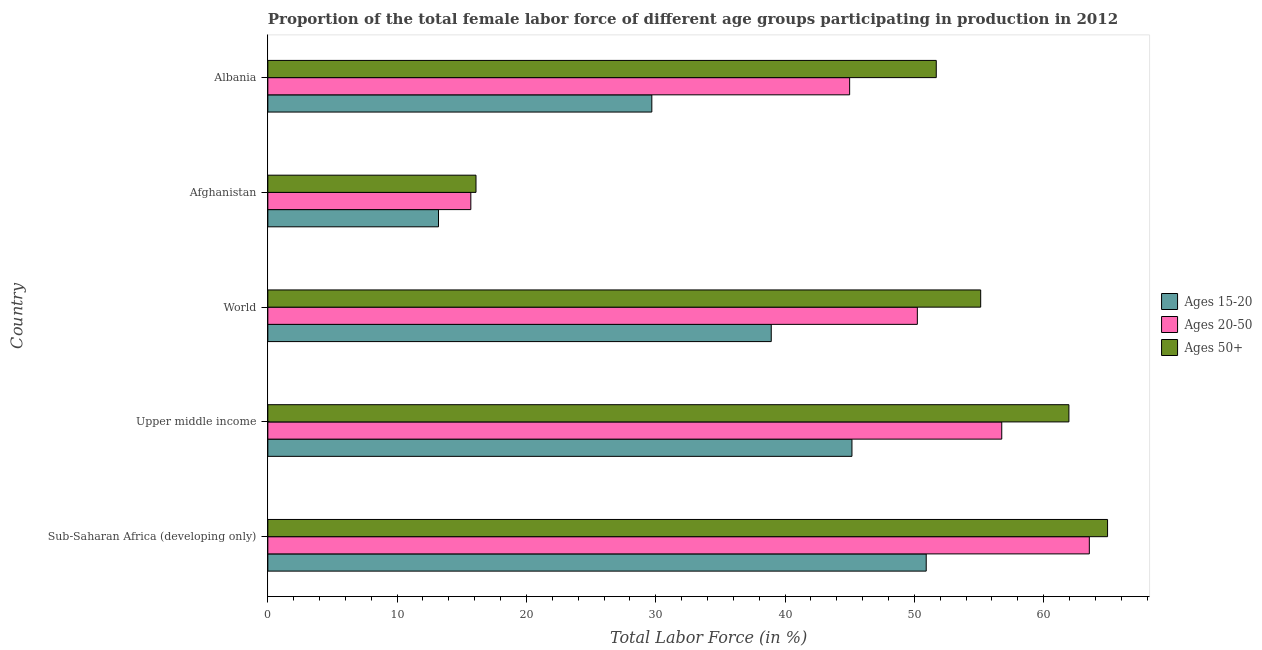What is the label of the 5th group of bars from the top?
Your response must be concise. Sub-Saharan Africa (developing only). What is the percentage of female labor force within the age group 15-20 in Afghanistan?
Your response must be concise. 13.2. Across all countries, what is the maximum percentage of female labor force within the age group 20-50?
Keep it short and to the point. 63.54. Across all countries, what is the minimum percentage of female labor force within the age group 20-50?
Your answer should be compact. 15.7. In which country was the percentage of female labor force above age 50 maximum?
Provide a short and direct response. Sub-Saharan Africa (developing only). In which country was the percentage of female labor force within the age group 15-20 minimum?
Make the answer very short. Afghanistan. What is the total percentage of female labor force above age 50 in the graph?
Ensure brevity in your answer.  249.84. What is the difference between the percentage of female labor force within the age group 20-50 in Afghanistan and that in World?
Your answer should be compact. -34.54. What is the difference between the percentage of female labor force above age 50 in Albania and the percentage of female labor force within the age group 15-20 in Upper middle income?
Give a very brief answer. 6.52. What is the average percentage of female labor force within the age group 15-20 per country?
Your answer should be compact. 35.59. What is the ratio of the percentage of female labor force above age 50 in Albania to that in Upper middle income?
Provide a succinct answer. 0.83. Is the difference between the percentage of female labor force above age 50 in Upper middle income and World greater than the difference between the percentage of female labor force within the age group 20-50 in Upper middle income and World?
Provide a succinct answer. Yes. What is the difference between the highest and the second highest percentage of female labor force above age 50?
Your response must be concise. 2.99. What is the difference between the highest and the lowest percentage of female labor force within the age group 15-20?
Give a very brief answer. 37.72. What does the 3rd bar from the top in Upper middle income represents?
Keep it short and to the point. Ages 15-20. What does the 3rd bar from the bottom in Afghanistan represents?
Provide a short and direct response. Ages 50+. Are all the bars in the graph horizontal?
Give a very brief answer. Yes. What is the difference between two consecutive major ticks on the X-axis?
Your answer should be very brief. 10. Does the graph contain grids?
Offer a very short reply. No. Where does the legend appear in the graph?
Ensure brevity in your answer.  Center right. How many legend labels are there?
Make the answer very short. 3. What is the title of the graph?
Your answer should be very brief. Proportion of the total female labor force of different age groups participating in production in 2012. Does "Primary education" appear as one of the legend labels in the graph?
Your response must be concise. No. What is the label or title of the X-axis?
Provide a short and direct response. Total Labor Force (in %). What is the label or title of the Y-axis?
Offer a very short reply. Country. What is the Total Labor Force (in %) of Ages 15-20 in Sub-Saharan Africa (developing only)?
Keep it short and to the point. 50.92. What is the Total Labor Force (in %) of Ages 20-50 in Sub-Saharan Africa (developing only)?
Give a very brief answer. 63.54. What is the Total Labor Force (in %) of Ages 50+ in Sub-Saharan Africa (developing only)?
Your answer should be very brief. 64.95. What is the Total Labor Force (in %) of Ages 15-20 in Upper middle income?
Your answer should be very brief. 45.18. What is the Total Labor Force (in %) in Ages 20-50 in Upper middle income?
Your answer should be very brief. 56.76. What is the Total Labor Force (in %) of Ages 50+ in Upper middle income?
Offer a very short reply. 61.96. What is the Total Labor Force (in %) in Ages 15-20 in World?
Offer a very short reply. 38.94. What is the Total Labor Force (in %) of Ages 20-50 in World?
Offer a very short reply. 50.24. What is the Total Labor Force (in %) of Ages 50+ in World?
Your response must be concise. 55.14. What is the Total Labor Force (in %) in Ages 15-20 in Afghanistan?
Offer a very short reply. 13.2. What is the Total Labor Force (in %) in Ages 20-50 in Afghanistan?
Keep it short and to the point. 15.7. What is the Total Labor Force (in %) in Ages 50+ in Afghanistan?
Provide a succinct answer. 16.1. What is the Total Labor Force (in %) of Ages 15-20 in Albania?
Ensure brevity in your answer.  29.7. What is the Total Labor Force (in %) in Ages 50+ in Albania?
Provide a short and direct response. 51.7. Across all countries, what is the maximum Total Labor Force (in %) in Ages 15-20?
Provide a short and direct response. 50.92. Across all countries, what is the maximum Total Labor Force (in %) in Ages 20-50?
Make the answer very short. 63.54. Across all countries, what is the maximum Total Labor Force (in %) in Ages 50+?
Offer a terse response. 64.95. Across all countries, what is the minimum Total Labor Force (in %) in Ages 15-20?
Provide a succinct answer. 13.2. Across all countries, what is the minimum Total Labor Force (in %) in Ages 20-50?
Make the answer very short. 15.7. Across all countries, what is the minimum Total Labor Force (in %) of Ages 50+?
Provide a succinct answer. 16.1. What is the total Total Labor Force (in %) of Ages 15-20 in the graph?
Your answer should be compact. 177.94. What is the total Total Labor Force (in %) of Ages 20-50 in the graph?
Provide a succinct answer. 231.24. What is the total Total Labor Force (in %) in Ages 50+ in the graph?
Your response must be concise. 249.84. What is the difference between the Total Labor Force (in %) in Ages 15-20 in Sub-Saharan Africa (developing only) and that in Upper middle income?
Offer a very short reply. 5.74. What is the difference between the Total Labor Force (in %) in Ages 20-50 in Sub-Saharan Africa (developing only) and that in Upper middle income?
Give a very brief answer. 6.77. What is the difference between the Total Labor Force (in %) in Ages 50+ in Sub-Saharan Africa (developing only) and that in Upper middle income?
Ensure brevity in your answer.  2.99. What is the difference between the Total Labor Force (in %) in Ages 15-20 in Sub-Saharan Africa (developing only) and that in World?
Your answer should be very brief. 11.99. What is the difference between the Total Labor Force (in %) in Ages 20-50 in Sub-Saharan Africa (developing only) and that in World?
Provide a short and direct response. 13.3. What is the difference between the Total Labor Force (in %) in Ages 50+ in Sub-Saharan Africa (developing only) and that in World?
Your answer should be very brief. 9.81. What is the difference between the Total Labor Force (in %) in Ages 15-20 in Sub-Saharan Africa (developing only) and that in Afghanistan?
Provide a succinct answer. 37.72. What is the difference between the Total Labor Force (in %) of Ages 20-50 in Sub-Saharan Africa (developing only) and that in Afghanistan?
Give a very brief answer. 47.84. What is the difference between the Total Labor Force (in %) in Ages 50+ in Sub-Saharan Africa (developing only) and that in Afghanistan?
Give a very brief answer. 48.85. What is the difference between the Total Labor Force (in %) of Ages 15-20 in Sub-Saharan Africa (developing only) and that in Albania?
Offer a very short reply. 21.22. What is the difference between the Total Labor Force (in %) in Ages 20-50 in Sub-Saharan Africa (developing only) and that in Albania?
Give a very brief answer. 18.54. What is the difference between the Total Labor Force (in %) in Ages 50+ in Sub-Saharan Africa (developing only) and that in Albania?
Give a very brief answer. 13.25. What is the difference between the Total Labor Force (in %) of Ages 15-20 in Upper middle income and that in World?
Provide a succinct answer. 6.24. What is the difference between the Total Labor Force (in %) of Ages 20-50 in Upper middle income and that in World?
Make the answer very short. 6.53. What is the difference between the Total Labor Force (in %) of Ages 50+ in Upper middle income and that in World?
Give a very brief answer. 6.82. What is the difference between the Total Labor Force (in %) of Ages 15-20 in Upper middle income and that in Afghanistan?
Ensure brevity in your answer.  31.98. What is the difference between the Total Labor Force (in %) in Ages 20-50 in Upper middle income and that in Afghanistan?
Offer a terse response. 41.06. What is the difference between the Total Labor Force (in %) in Ages 50+ in Upper middle income and that in Afghanistan?
Give a very brief answer. 45.86. What is the difference between the Total Labor Force (in %) of Ages 15-20 in Upper middle income and that in Albania?
Give a very brief answer. 15.48. What is the difference between the Total Labor Force (in %) in Ages 20-50 in Upper middle income and that in Albania?
Offer a terse response. 11.76. What is the difference between the Total Labor Force (in %) in Ages 50+ in Upper middle income and that in Albania?
Give a very brief answer. 10.26. What is the difference between the Total Labor Force (in %) of Ages 15-20 in World and that in Afghanistan?
Provide a succinct answer. 25.74. What is the difference between the Total Labor Force (in %) of Ages 20-50 in World and that in Afghanistan?
Your answer should be compact. 34.54. What is the difference between the Total Labor Force (in %) in Ages 50+ in World and that in Afghanistan?
Make the answer very short. 39.04. What is the difference between the Total Labor Force (in %) of Ages 15-20 in World and that in Albania?
Provide a succinct answer. 9.24. What is the difference between the Total Labor Force (in %) of Ages 20-50 in World and that in Albania?
Keep it short and to the point. 5.24. What is the difference between the Total Labor Force (in %) of Ages 50+ in World and that in Albania?
Your response must be concise. 3.44. What is the difference between the Total Labor Force (in %) of Ages 15-20 in Afghanistan and that in Albania?
Give a very brief answer. -16.5. What is the difference between the Total Labor Force (in %) in Ages 20-50 in Afghanistan and that in Albania?
Your answer should be very brief. -29.3. What is the difference between the Total Labor Force (in %) in Ages 50+ in Afghanistan and that in Albania?
Provide a short and direct response. -35.6. What is the difference between the Total Labor Force (in %) of Ages 15-20 in Sub-Saharan Africa (developing only) and the Total Labor Force (in %) of Ages 20-50 in Upper middle income?
Make the answer very short. -5.84. What is the difference between the Total Labor Force (in %) in Ages 15-20 in Sub-Saharan Africa (developing only) and the Total Labor Force (in %) in Ages 50+ in Upper middle income?
Provide a short and direct response. -11.04. What is the difference between the Total Labor Force (in %) in Ages 20-50 in Sub-Saharan Africa (developing only) and the Total Labor Force (in %) in Ages 50+ in Upper middle income?
Give a very brief answer. 1.58. What is the difference between the Total Labor Force (in %) of Ages 15-20 in Sub-Saharan Africa (developing only) and the Total Labor Force (in %) of Ages 20-50 in World?
Make the answer very short. 0.69. What is the difference between the Total Labor Force (in %) of Ages 15-20 in Sub-Saharan Africa (developing only) and the Total Labor Force (in %) of Ages 50+ in World?
Offer a very short reply. -4.21. What is the difference between the Total Labor Force (in %) of Ages 20-50 in Sub-Saharan Africa (developing only) and the Total Labor Force (in %) of Ages 50+ in World?
Give a very brief answer. 8.4. What is the difference between the Total Labor Force (in %) in Ages 15-20 in Sub-Saharan Africa (developing only) and the Total Labor Force (in %) in Ages 20-50 in Afghanistan?
Your answer should be very brief. 35.22. What is the difference between the Total Labor Force (in %) in Ages 15-20 in Sub-Saharan Africa (developing only) and the Total Labor Force (in %) in Ages 50+ in Afghanistan?
Ensure brevity in your answer.  34.82. What is the difference between the Total Labor Force (in %) of Ages 20-50 in Sub-Saharan Africa (developing only) and the Total Labor Force (in %) of Ages 50+ in Afghanistan?
Ensure brevity in your answer.  47.44. What is the difference between the Total Labor Force (in %) in Ages 15-20 in Sub-Saharan Africa (developing only) and the Total Labor Force (in %) in Ages 20-50 in Albania?
Ensure brevity in your answer.  5.92. What is the difference between the Total Labor Force (in %) in Ages 15-20 in Sub-Saharan Africa (developing only) and the Total Labor Force (in %) in Ages 50+ in Albania?
Keep it short and to the point. -0.78. What is the difference between the Total Labor Force (in %) of Ages 20-50 in Sub-Saharan Africa (developing only) and the Total Labor Force (in %) of Ages 50+ in Albania?
Ensure brevity in your answer.  11.84. What is the difference between the Total Labor Force (in %) of Ages 15-20 in Upper middle income and the Total Labor Force (in %) of Ages 20-50 in World?
Your answer should be compact. -5.06. What is the difference between the Total Labor Force (in %) of Ages 15-20 in Upper middle income and the Total Labor Force (in %) of Ages 50+ in World?
Your response must be concise. -9.96. What is the difference between the Total Labor Force (in %) in Ages 20-50 in Upper middle income and the Total Labor Force (in %) in Ages 50+ in World?
Offer a very short reply. 1.63. What is the difference between the Total Labor Force (in %) in Ages 15-20 in Upper middle income and the Total Labor Force (in %) in Ages 20-50 in Afghanistan?
Your answer should be very brief. 29.48. What is the difference between the Total Labor Force (in %) in Ages 15-20 in Upper middle income and the Total Labor Force (in %) in Ages 50+ in Afghanistan?
Give a very brief answer. 29.08. What is the difference between the Total Labor Force (in %) in Ages 20-50 in Upper middle income and the Total Labor Force (in %) in Ages 50+ in Afghanistan?
Make the answer very short. 40.66. What is the difference between the Total Labor Force (in %) in Ages 15-20 in Upper middle income and the Total Labor Force (in %) in Ages 20-50 in Albania?
Offer a terse response. 0.18. What is the difference between the Total Labor Force (in %) of Ages 15-20 in Upper middle income and the Total Labor Force (in %) of Ages 50+ in Albania?
Your response must be concise. -6.52. What is the difference between the Total Labor Force (in %) of Ages 20-50 in Upper middle income and the Total Labor Force (in %) of Ages 50+ in Albania?
Make the answer very short. 5.06. What is the difference between the Total Labor Force (in %) of Ages 15-20 in World and the Total Labor Force (in %) of Ages 20-50 in Afghanistan?
Your response must be concise. 23.24. What is the difference between the Total Labor Force (in %) of Ages 15-20 in World and the Total Labor Force (in %) of Ages 50+ in Afghanistan?
Make the answer very short. 22.84. What is the difference between the Total Labor Force (in %) of Ages 20-50 in World and the Total Labor Force (in %) of Ages 50+ in Afghanistan?
Your answer should be very brief. 34.14. What is the difference between the Total Labor Force (in %) of Ages 15-20 in World and the Total Labor Force (in %) of Ages 20-50 in Albania?
Offer a terse response. -6.06. What is the difference between the Total Labor Force (in %) of Ages 15-20 in World and the Total Labor Force (in %) of Ages 50+ in Albania?
Your response must be concise. -12.76. What is the difference between the Total Labor Force (in %) in Ages 20-50 in World and the Total Labor Force (in %) in Ages 50+ in Albania?
Give a very brief answer. -1.46. What is the difference between the Total Labor Force (in %) in Ages 15-20 in Afghanistan and the Total Labor Force (in %) in Ages 20-50 in Albania?
Give a very brief answer. -31.8. What is the difference between the Total Labor Force (in %) of Ages 15-20 in Afghanistan and the Total Labor Force (in %) of Ages 50+ in Albania?
Keep it short and to the point. -38.5. What is the difference between the Total Labor Force (in %) in Ages 20-50 in Afghanistan and the Total Labor Force (in %) in Ages 50+ in Albania?
Your response must be concise. -36. What is the average Total Labor Force (in %) in Ages 15-20 per country?
Provide a succinct answer. 35.59. What is the average Total Labor Force (in %) of Ages 20-50 per country?
Offer a terse response. 46.25. What is the average Total Labor Force (in %) in Ages 50+ per country?
Your answer should be compact. 49.97. What is the difference between the Total Labor Force (in %) of Ages 15-20 and Total Labor Force (in %) of Ages 20-50 in Sub-Saharan Africa (developing only)?
Provide a short and direct response. -12.62. What is the difference between the Total Labor Force (in %) in Ages 15-20 and Total Labor Force (in %) in Ages 50+ in Sub-Saharan Africa (developing only)?
Your answer should be compact. -14.03. What is the difference between the Total Labor Force (in %) of Ages 20-50 and Total Labor Force (in %) of Ages 50+ in Sub-Saharan Africa (developing only)?
Provide a short and direct response. -1.41. What is the difference between the Total Labor Force (in %) in Ages 15-20 and Total Labor Force (in %) in Ages 20-50 in Upper middle income?
Provide a short and direct response. -11.59. What is the difference between the Total Labor Force (in %) of Ages 15-20 and Total Labor Force (in %) of Ages 50+ in Upper middle income?
Ensure brevity in your answer.  -16.78. What is the difference between the Total Labor Force (in %) in Ages 20-50 and Total Labor Force (in %) in Ages 50+ in Upper middle income?
Ensure brevity in your answer.  -5.19. What is the difference between the Total Labor Force (in %) of Ages 15-20 and Total Labor Force (in %) of Ages 20-50 in World?
Provide a short and direct response. -11.3. What is the difference between the Total Labor Force (in %) of Ages 15-20 and Total Labor Force (in %) of Ages 50+ in World?
Offer a terse response. -16.2. What is the difference between the Total Labor Force (in %) of Ages 20-50 and Total Labor Force (in %) of Ages 50+ in World?
Keep it short and to the point. -4.9. What is the difference between the Total Labor Force (in %) in Ages 15-20 and Total Labor Force (in %) in Ages 20-50 in Afghanistan?
Offer a very short reply. -2.5. What is the difference between the Total Labor Force (in %) of Ages 15-20 and Total Labor Force (in %) of Ages 50+ in Afghanistan?
Your answer should be very brief. -2.9. What is the difference between the Total Labor Force (in %) in Ages 15-20 and Total Labor Force (in %) in Ages 20-50 in Albania?
Make the answer very short. -15.3. What is the ratio of the Total Labor Force (in %) in Ages 15-20 in Sub-Saharan Africa (developing only) to that in Upper middle income?
Provide a succinct answer. 1.13. What is the ratio of the Total Labor Force (in %) in Ages 20-50 in Sub-Saharan Africa (developing only) to that in Upper middle income?
Provide a succinct answer. 1.12. What is the ratio of the Total Labor Force (in %) in Ages 50+ in Sub-Saharan Africa (developing only) to that in Upper middle income?
Keep it short and to the point. 1.05. What is the ratio of the Total Labor Force (in %) of Ages 15-20 in Sub-Saharan Africa (developing only) to that in World?
Make the answer very short. 1.31. What is the ratio of the Total Labor Force (in %) of Ages 20-50 in Sub-Saharan Africa (developing only) to that in World?
Make the answer very short. 1.26. What is the ratio of the Total Labor Force (in %) of Ages 50+ in Sub-Saharan Africa (developing only) to that in World?
Ensure brevity in your answer.  1.18. What is the ratio of the Total Labor Force (in %) of Ages 15-20 in Sub-Saharan Africa (developing only) to that in Afghanistan?
Your answer should be very brief. 3.86. What is the ratio of the Total Labor Force (in %) in Ages 20-50 in Sub-Saharan Africa (developing only) to that in Afghanistan?
Make the answer very short. 4.05. What is the ratio of the Total Labor Force (in %) of Ages 50+ in Sub-Saharan Africa (developing only) to that in Afghanistan?
Provide a succinct answer. 4.03. What is the ratio of the Total Labor Force (in %) of Ages 15-20 in Sub-Saharan Africa (developing only) to that in Albania?
Your answer should be compact. 1.71. What is the ratio of the Total Labor Force (in %) of Ages 20-50 in Sub-Saharan Africa (developing only) to that in Albania?
Your answer should be compact. 1.41. What is the ratio of the Total Labor Force (in %) in Ages 50+ in Sub-Saharan Africa (developing only) to that in Albania?
Ensure brevity in your answer.  1.26. What is the ratio of the Total Labor Force (in %) in Ages 15-20 in Upper middle income to that in World?
Your answer should be very brief. 1.16. What is the ratio of the Total Labor Force (in %) of Ages 20-50 in Upper middle income to that in World?
Your response must be concise. 1.13. What is the ratio of the Total Labor Force (in %) in Ages 50+ in Upper middle income to that in World?
Your answer should be compact. 1.12. What is the ratio of the Total Labor Force (in %) of Ages 15-20 in Upper middle income to that in Afghanistan?
Your response must be concise. 3.42. What is the ratio of the Total Labor Force (in %) of Ages 20-50 in Upper middle income to that in Afghanistan?
Offer a terse response. 3.62. What is the ratio of the Total Labor Force (in %) in Ages 50+ in Upper middle income to that in Afghanistan?
Offer a very short reply. 3.85. What is the ratio of the Total Labor Force (in %) in Ages 15-20 in Upper middle income to that in Albania?
Give a very brief answer. 1.52. What is the ratio of the Total Labor Force (in %) of Ages 20-50 in Upper middle income to that in Albania?
Offer a very short reply. 1.26. What is the ratio of the Total Labor Force (in %) in Ages 50+ in Upper middle income to that in Albania?
Offer a terse response. 1.2. What is the ratio of the Total Labor Force (in %) of Ages 15-20 in World to that in Afghanistan?
Give a very brief answer. 2.95. What is the ratio of the Total Labor Force (in %) in Ages 20-50 in World to that in Afghanistan?
Keep it short and to the point. 3.2. What is the ratio of the Total Labor Force (in %) of Ages 50+ in World to that in Afghanistan?
Provide a succinct answer. 3.42. What is the ratio of the Total Labor Force (in %) in Ages 15-20 in World to that in Albania?
Offer a very short reply. 1.31. What is the ratio of the Total Labor Force (in %) of Ages 20-50 in World to that in Albania?
Offer a very short reply. 1.12. What is the ratio of the Total Labor Force (in %) in Ages 50+ in World to that in Albania?
Your answer should be compact. 1.07. What is the ratio of the Total Labor Force (in %) in Ages 15-20 in Afghanistan to that in Albania?
Your response must be concise. 0.44. What is the ratio of the Total Labor Force (in %) in Ages 20-50 in Afghanistan to that in Albania?
Keep it short and to the point. 0.35. What is the ratio of the Total Labor Force (in %) in Ages 50+ in Afghanistan to that in Albania?
Your answer should be very brief. 0.31. What is the difference between the highest and the second highest Total Labor Force (in %) in Ages 15-20?
Give a very brief answer. 5.74. What is the difference between the highest and the second highest Total Labor Force (in %) of Ages 20-50?
Offer a terse response. 6.77. What is the difference between the highest and the second highest Total Labor Force (in %) in Ages 50+?
Make the answer very short. 2.99. What is the difference between the highest and the lowest Total Labor Force (in %) in Ages 15-20?
Your response must be concise. 37.72. What is the difference between the highest and the lowest Total Labor Force (in %) in Ages 20-50?
Offer a terse response. 47.84. What is the difference between the highest and the lowest Total Labor Force (in %) of Ages 50+?
Give a very brief answer. 48.85. 